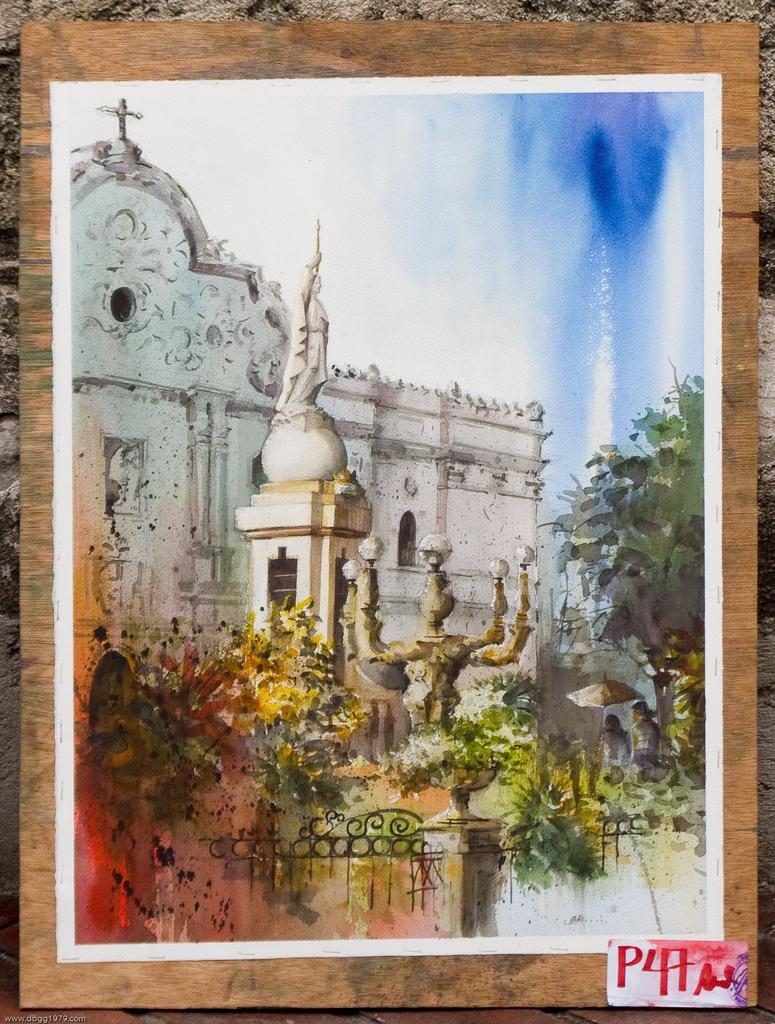What is depicted on the poster in the image? The poster contains a drawing of a building, a statue, trees, and the sky. What other elements can be found on the poster? There is text at the bottom of the image. How does the team work together to sort the brake in the image? There is no team, brake, or sorting activity present in the image; it features a poster with drawings and text. 